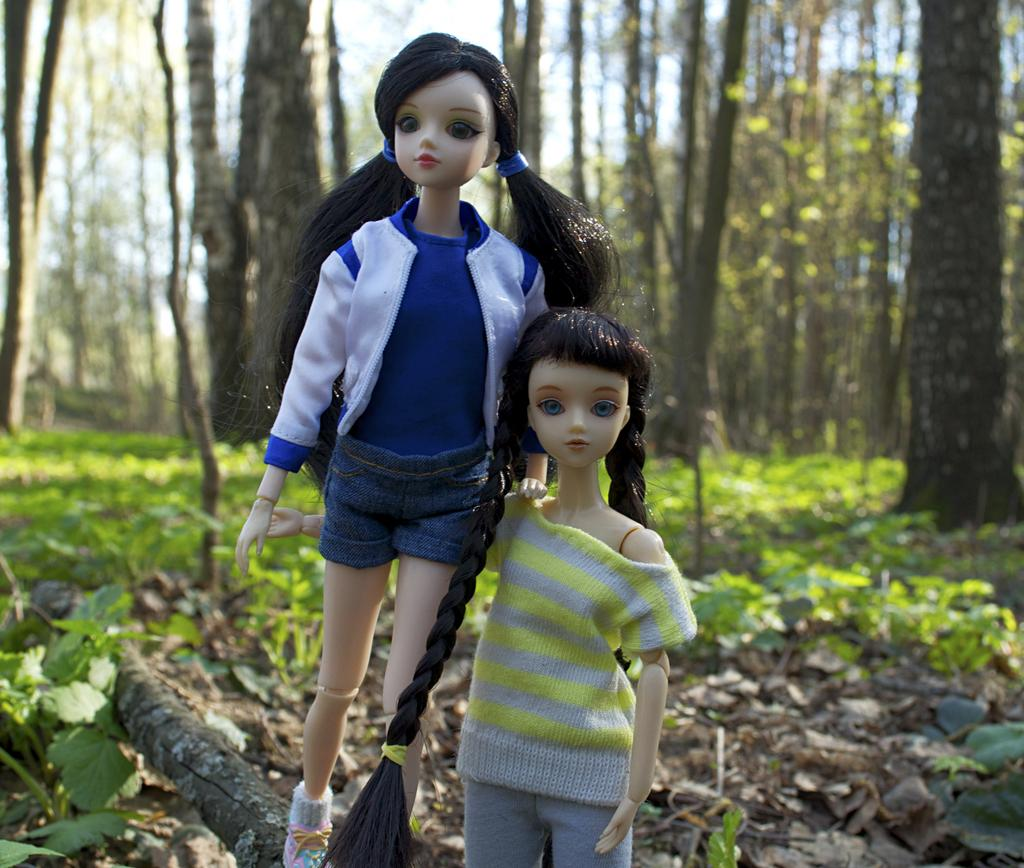What is placed on the tree bark in the image? There are dolls placed on the tree bark. What type of natural structures can be seen in the image? There are trees visible in the image. What type of vegetation is present in the image? There are plants in the image. What type of jelly can be seen dripping from the leaves in the image? There is no jelly present in the image; it features dolls on tree bark and trees with plants. 